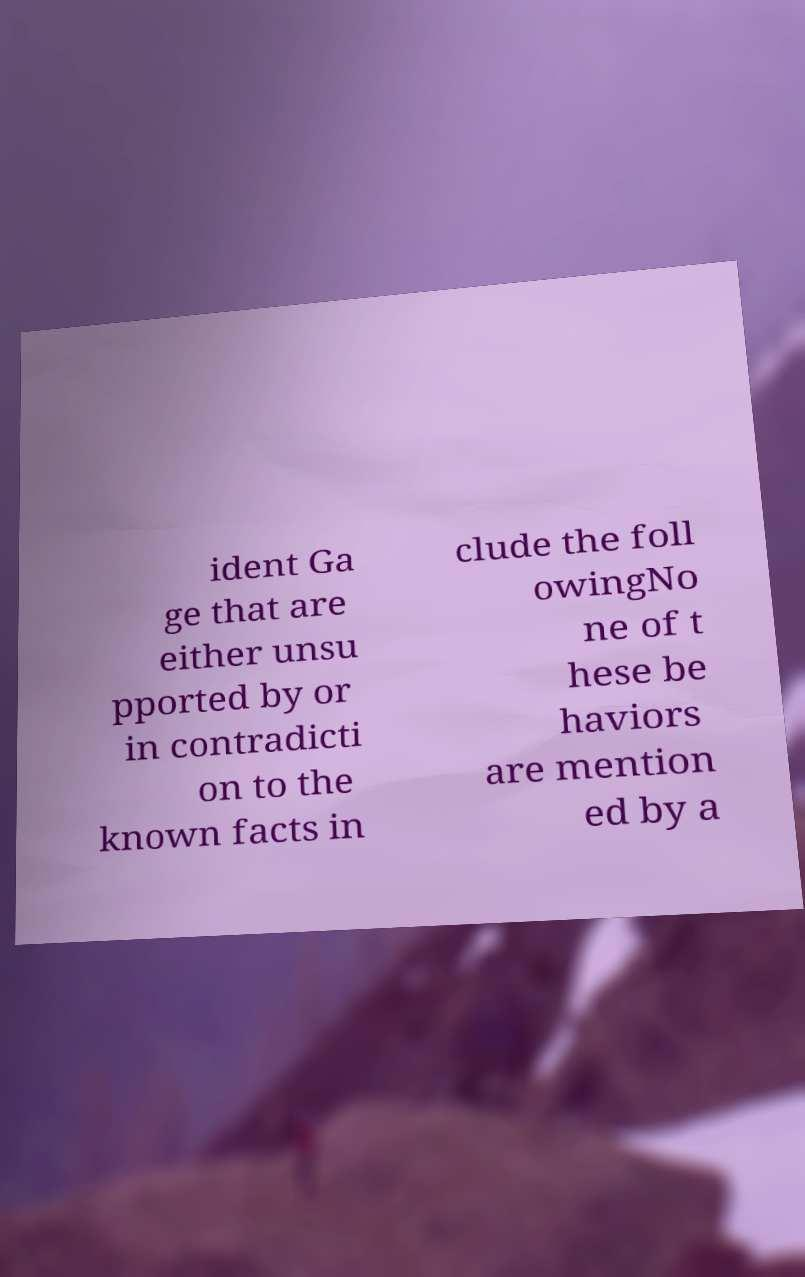Can you read and provide the text displayed in the image?This photo seems to have some interesting text. Can you extract and type it out for me? ident Ga ge that are either unsu pported by or in contradicti on to the known facts in clude the foll owingNo ne of t hese be haviors are mention ed by a 